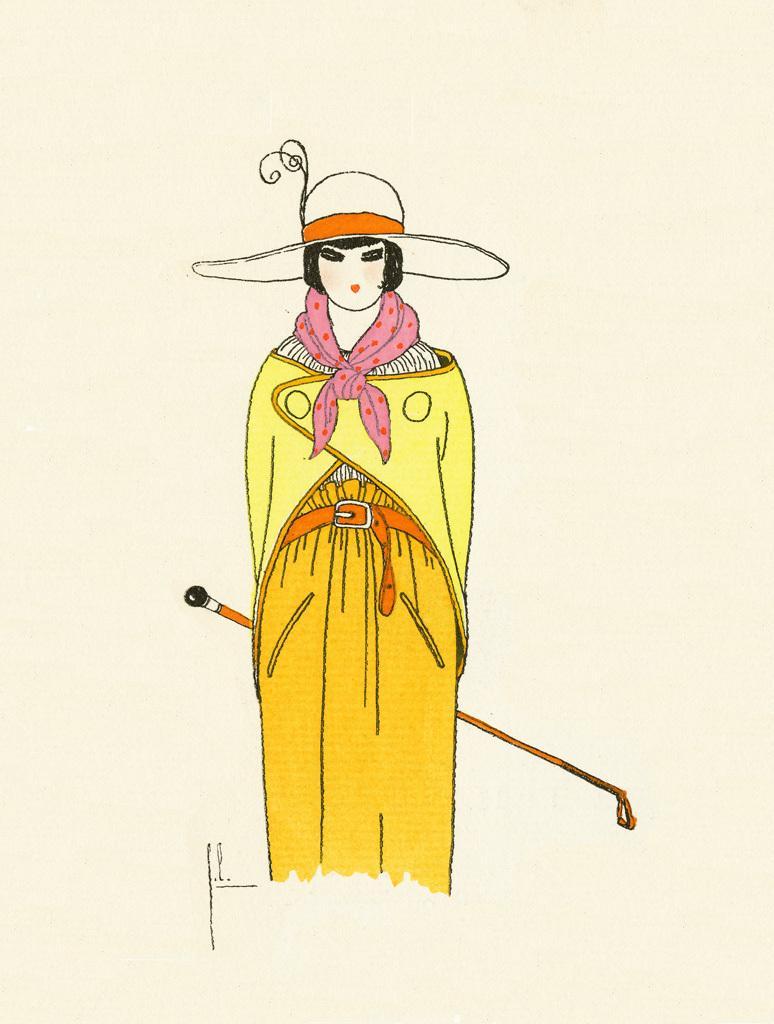In one or two sentences, can you explain what this image depicts? In this image I can see a depiction of a person standing. I can see this as a woman holding a stick. 